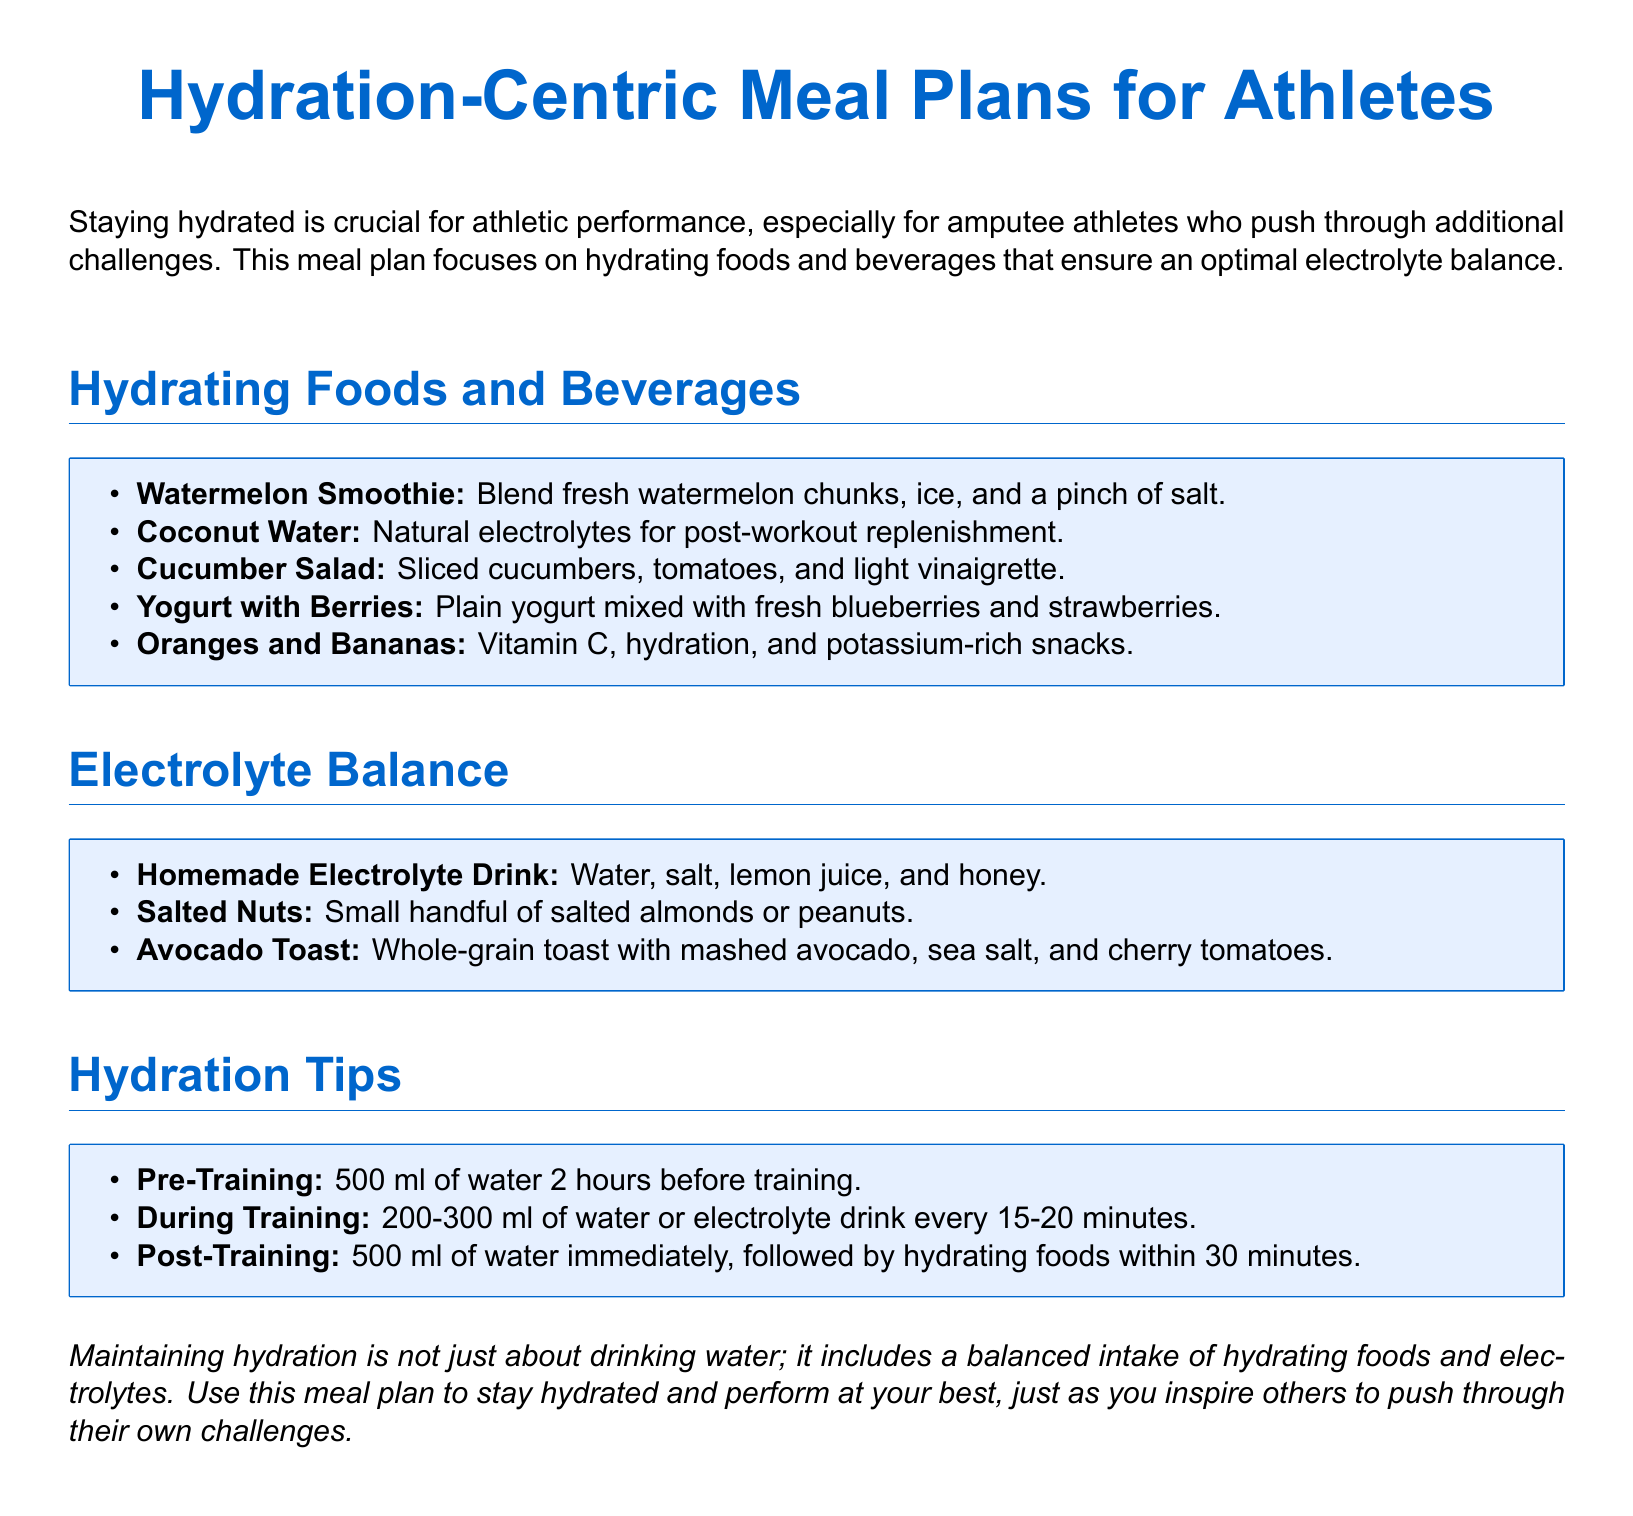what is the primary focus of the meal plan? The primary focus of the meal plan is on hydrating foods and beverages.
Answer: hydrating foods and beverages what is a recommended pre-training hydration amount? The document states to drink 500 ml of water 2 hours before training.
Answer: 500 ml which fruit is suggested for a smoothie? The meal plan mentions blending fresh watermelon chunks in the smoothie.
Answer: watermelon what is a recommended drink for electrolyte replenishment? The document recommends coconut water for post-workout replenishment.
Answer: coconut water what type of salad is mentioned as hydrating? It mentions a cucumber salad consisting of sliced cucumbers, tomatoes, and light vinaigrette.
Answer: cucumber salad what homemade drink is suggested for electrolyte balance? The document suggests a homemade electrolyte drink made with water, salt, lemon juice, and honey.
Answer: homemade electrolyte drink how often should fluids be consumed during training? The document suggests consuming 200-300 ml of water or an electrolyte drink every 15-20 minutes.
Answer: every 15-20 minutes what is an example of a hydrating snack? An example of a hydrating snack mentioned is yogurt with berries.
Answer: yogurt with berries what should be consumed immediately after training? The document states to drink 500 ml of water immediately after training.
Answer: 500 ml of water 